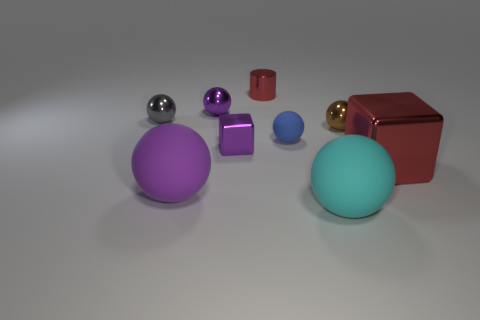Subtract all big spheres. How many spheres are left? 4 Subtract all cyan spheres. How many spheres are left? 5 Subtract 3 spheres. How many spheres are left? 3 Subtract all red balls. Subtract all gray cubes. How many balls are left? 6 Add 1 blocks. How many objects exist? 10 Subtract 1 purple balls. How many objects are left? 8 Subtract all blocks. How many objects are left? 7 Subtract all big yellow metallic cylinders. Subtract all metallic spheres. How many objects are left? 6 Add 2 blue balls. How many blue balls are left? 3 Add 7 blue rubber balls. How many blue rubber balls exist? 8 